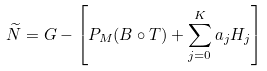Convert formula to latex. <formula><loc_0><loc_0><loc_500><loc_500>\widetilde { N } = G - \left [ P _ { M } ( B \circ T ) + \sum _ { j = 0 } ^ { K } a _ { j } H _ { j } \right ]</formula> 